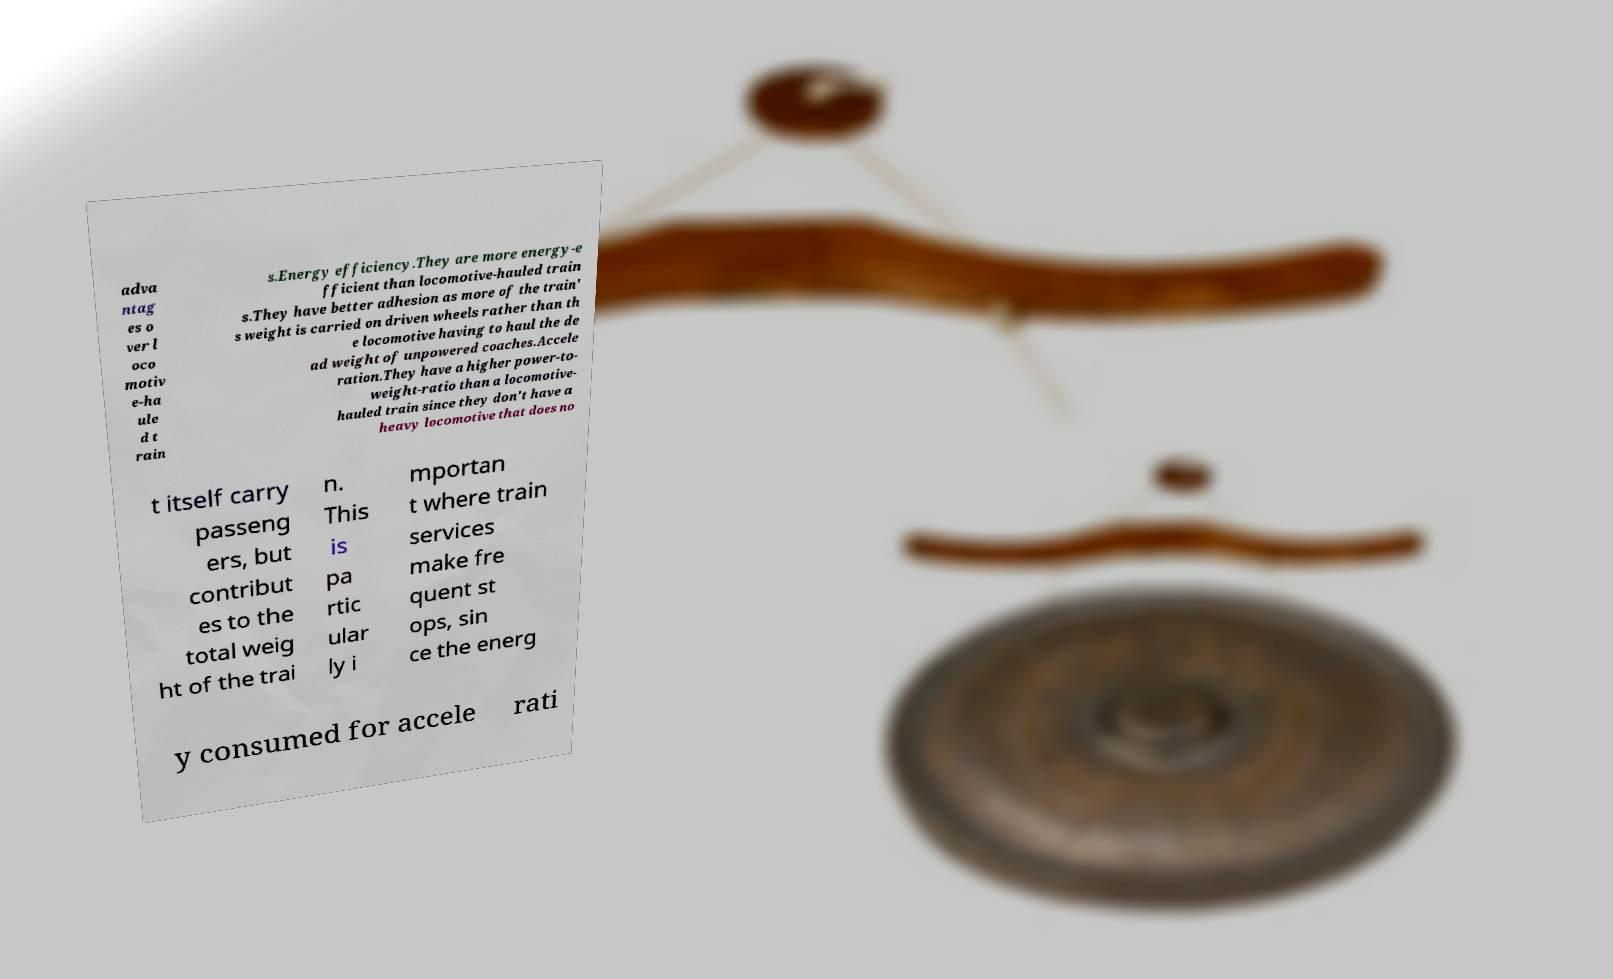Please identify and transcribe the text found in this image. adva ntag es o ver l oco motiv e-ha ule d t rain s.Energy efficiency.They are more energy-e fficient than locomotive-hauled train s.They have better adhesion as more of the train' s weight is carried on driven wheels rather than th e locomotive having to haul the de ad weight of unpowered coaches.Accele ration.They have a higher power-to- weight-ratio than a locomotive- hauled train since they don't have a heavy locomotive that does no t itself carry passeng ers, but contribut es to the total weig ht of the trai n. This is pa rtic ular ly i mportan t where train services make fre quent st ops, sin ce the energ y consumed for accele rati 